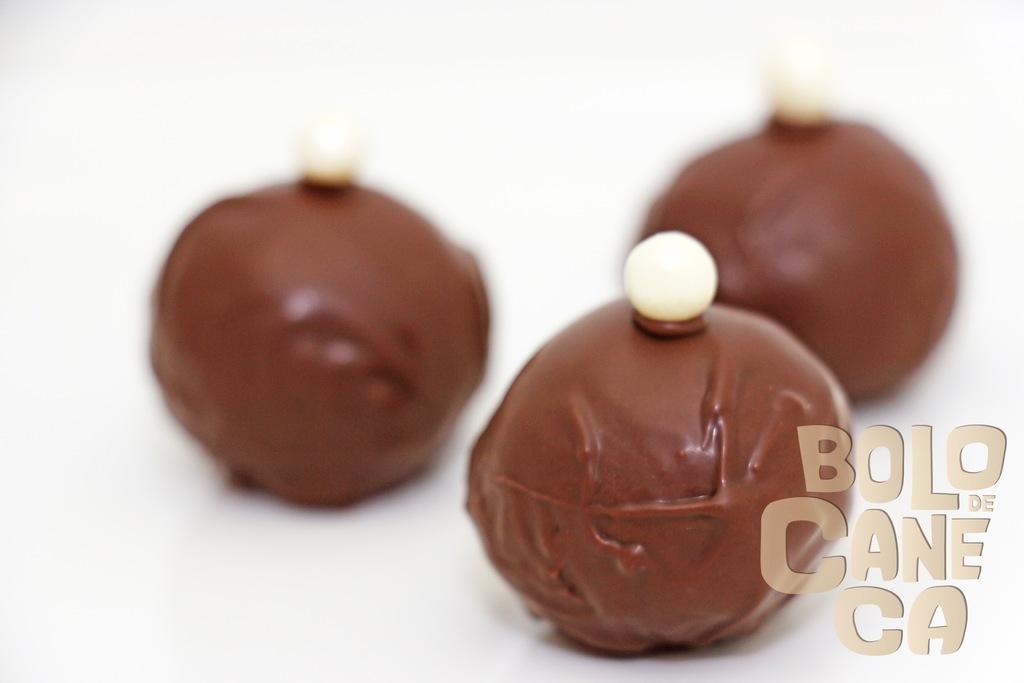Describe this image in one or two sentences. This is an image of the poster where we can see some chocolate balls and water mark at the bottom of image. 